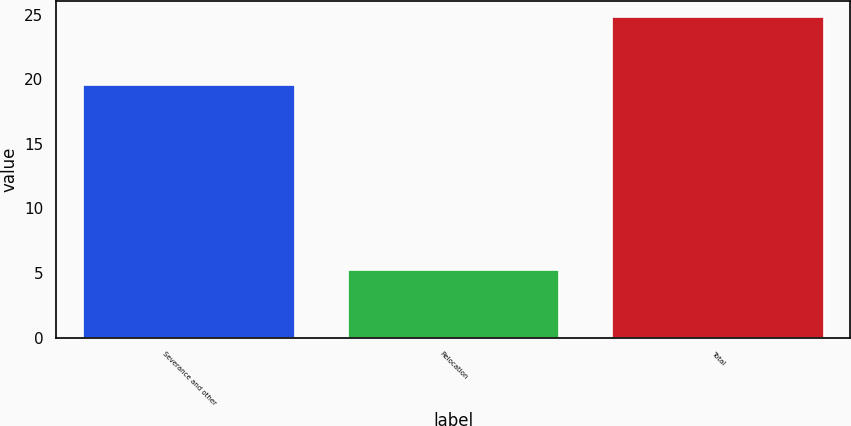<chart> <loc_0><loc_0><loc_500><loc_500><bar_chart><fcel>Severance and other<fcel>Relocation<fcel>Total<nl><fcel>19.6<fcel>5.2<fcel>24.8<nl></chart> 